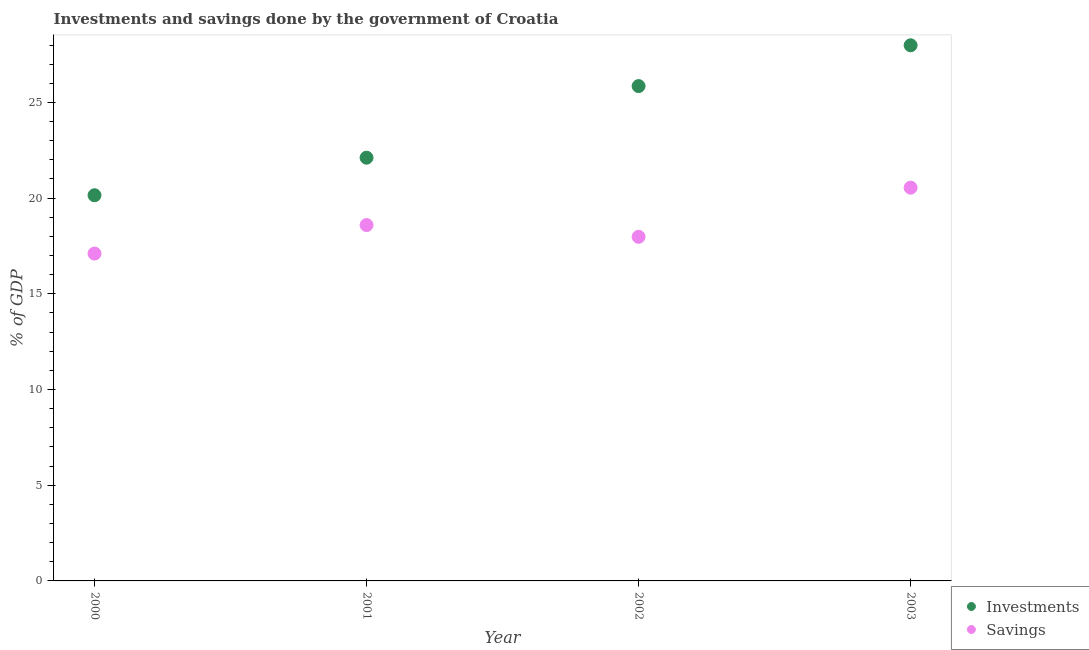Is the number of dotlines equal to the number of legend labels?
Provide a short and direct response. Yes. What is the savings of government in 2003?
Offer a terse response. 20.55. Across all years, what is the maximum investments of government?
Provide a succinct answer. 27.99. Across all years, what is the minimum investments of government?
Your answer should be compact. 20.15. What is the total investments of government in the graph?
Provide a short and direct response. 96.1. What is the difference between the investments of government in 2000 and that in 2001?
Keep it short and to the point. -1.96. What is the difference between the investments of government in 2003 and the savings of government in 2001?
Keep it short and to the point. 9.39. What is the average savings of government per year?
Your response must be concise. 18.56. In the year 2003, what is the difference between the savings of government and investments of government?
Give a very brief answer. -7.44. What is the ratio of the investments of government in 2000 to that in 2003?
Your answer should be very brief. 0.72. What is the difference between the highest and the second highest savings of government?
Offer a very short reply. 1.95. What is the difference between the highest and the lowest investments of government?
Provide a short and direct response. 7.83. In how many years, is the savings of government greater than the average savings of government taken over all years?
Give a very brief answer. 2. Does the savings of government monotonically increase over the years?
Ensure brevity in your answer.  No. How many dotlines are there?
Your answer should be compact. 2. What is the difference between two consecutive major ticks on the Y-axis?
Offer a very short reply. 5. Where does the legend appear in the graph?
Give a very brief answer. Bottom right. How many legend labels are there?
Your response must be concise. 2. What is the title of the graph?
Your answer should be very brief. Investments and savings done by the government of Croatia. What is the label or title of the Y-axis?
Ensure brevity in your answer.  % of GDP. What is the % of GDP of Investments in 2000?
Your response must be concise. 20.15. What is the % of GDP of Savings in 2000?
Offer a very short reply. 17.1. What is the % of GDP of Investments in 2001?
Ensure brevity in your answer.  22.11. What is the % of GDP in Savings in 2001?
Offer a very short reply. 18.59. What is the % of GDP in Investments in 2002?
Your answer should be very brief. 25.85. What is the % of GDP in Savings in 2002?
Offer a terse response. 17.98. What is the % of GDP in Investments in 2003?
Provide a short and direct response. 27.99. What is the % of GDP in Savings in 2003?
Your answer should be compact. 20.55. Across all years, what is the maximum % of GDP in Investments?
Give a very brief answer. 27.99. Across all years, what is the maximum % of GDP of Savings?
Provide a succinct answer. 20.55. Across all years, what is the minimum % of GDP in Investments?
Provide a short and direct response. 20.15. Across all years, what is the minimum % of GDP of Savings?
Ensure brevity in your answer.  17.1. What is the total % of GDP in Investments in the graph?
Keep it short and to the point. 96.1. What is the total % of GDP of Savings in the graph?
Your answer should be very brief. 74.22. What is the difference between the % of GDP of Investments in 2000 and that in 2001?
Your answer should be very brief. -1.96. What is the difference between the % of GDP in Savings in 2000 and that in 2001?
Offer a terse response. -1.49. What is the difference between the % of GDP of Investments in 2000 and that in 2002?
Keep it short and to the point. -5.7. What is the difference between the % of GDP of Savings in 2000 and that in 2002?
Provide a short and direct response. -0.87. What is the difference between the % of GDP of Investments in 2000 and that in 2003?
Keep it short and to the point. -7.83. What is the difference between the % of GDP in Savings in 2000 and that in 2003?
Keep it short and to the point. -3.44. What is the difference between the % of GDP of Investments in 2001 and that in 2002?
Provide a succinct answer. -3.74. What is the difference between the % of GDP of Savings in 2001 and that in 2002?
Your answer should be compact. 0.62. What is the difference between the % of GDP of Investments in 2001 and that in 2003?
Provide a succinct answer. -5.87. What is the difference between the % of GDP of Savings in 2001 and that in 2003?
Provide a short and direct response. -1.95. What is the difference between the % of GDP of Investments in 2002 and that in 2003?
Provide a short and direct response. -2.13. What is the difference between the % of GDP in Savings in 2002 and that in 2003?
Your response must be concise. -2.57. What is the difference between the % of GDP of Investments in 2000 and the % of GDP of Savings in 2001?
Provide a succinct answer. 1.56. What is the difference between the % of GDP in Investments in 2000 and the % of GDP in Savings in 2002?
Your answer should be compact. 2.17. What is the difference between the % of GDP of Investments in 2000 and the % of GDP of Savings in 2003?
Your answer should be very brief. -0.4. What is the difference between the % of GDP in Investments in 2001 and the % of GDP in Savings in 2002?
Offer a very short reply. 4.13. What is the difference between the % of GDP of Investments in 2001 and the % of GDP of Savings in 2003?
Offer a terse response. 1.57. What is the difference between the % of GDP of Investments in 2002 and the % of GDP of Savings in 2003?
Make the answer very short. 5.31. What is the average % of GDP of Investments per year?
Your answer should be very brief. 24.03. What is the average % of GDP in Savings per year?
Offer a very short reply. 18.56. In the year 2000, what is the difference between the % of GDP of Investments and % of GDP of Savings?
Offer a very short reply. 3.05. In the year 2001, what is the difference between the % of GDP in Investments and % of GDP in Savings?
Provide a succinct answer. 3.52. In the year 2002, what is the difference between the % of GDP of Investments and % of GDP of Savings?
Keep it short and to the point. 7.88. In the year 2003, what is the difference between the % of GDP of Investments and % of GDP of Savings?
Make the answer very short. 7.44. What is the ratio of the % of GDP of Investments in 2000 to that in 2001?
Keep it short and to the point. 0.91. What is the ratio of the % of GDP in Savings in 2000 to that in 2001?
Make the answer very short. 0.92. What is the ratio of the % of GDP of Investments in 2000 to that in 2002?
Offer a very short reply. 0.78. What is the ratio of the % of GDP in Savings in 2000 to that in 2002?
Ensure brevity in your answer.  0.95. What is the ratio of the % of GDP of Investments in 2000 to that in 2003?
Your answer should be very brief. 0.72. What is the ratio of the % of GDP of Savings in 2000 to that in 2003?
Your answer should be very brief. 0.83. What is the ratio of the % of GDP of Investments in 2001 to that in 2002?
Provide a succinct answer. 0.86. What is the ratio of the % of GDP of Savings in 2001 to that in 2002?
Give a very brief answer. 1.03. What is the ratio of the % of GDP in Investments in 2001 to that in 2003?
Make the answer very short. 0.79. What is the ratio of the % of GDP of Savings in 2001 to that in 2003?
Your answer should be very brief. 0.9. What is the ratio of the % of GDP of Investments in 2002 to that in 2003?
Your answer should be very brief. 0.92. What is the ratio of the % of GDP of Savings in 2002 to that in 2003?
Provide a succinct answer. 0.88. What is the difference between the highest and the second highest % of GDP in Investments?
Make the answer very short. 2.13. What is the difference between the highest and the second highest % of GDP in Savings?
Keep it short and to the point. 1.95. What is the difference between the highest and the lowest % of GDP in Investments?
Give a very brief answer. 7.83. What is the difference between the highest and the lowest % of GDP of Savings?
Provide a short and direct response. 3.44. 